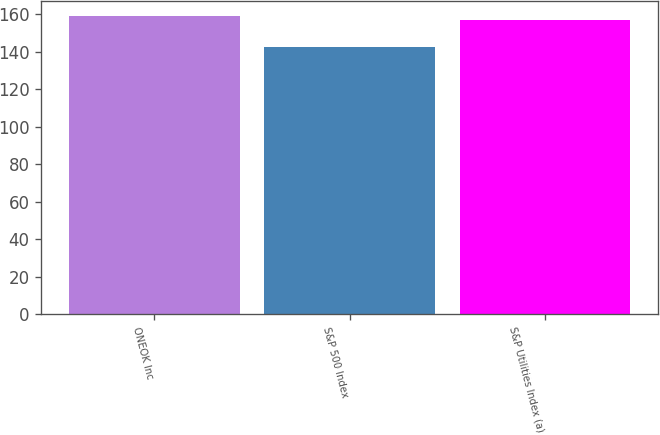Convert chart. <chart><loc_0><loc_0><loc_500><loc_500><bar_chart><fcel>ONEOK Inc<fcel>S&P 500 Index<fcel>S&P Utilities Index (a)<nl><fcel>159.26<fcel>142.69<fcel>156.91<nl></chart> 